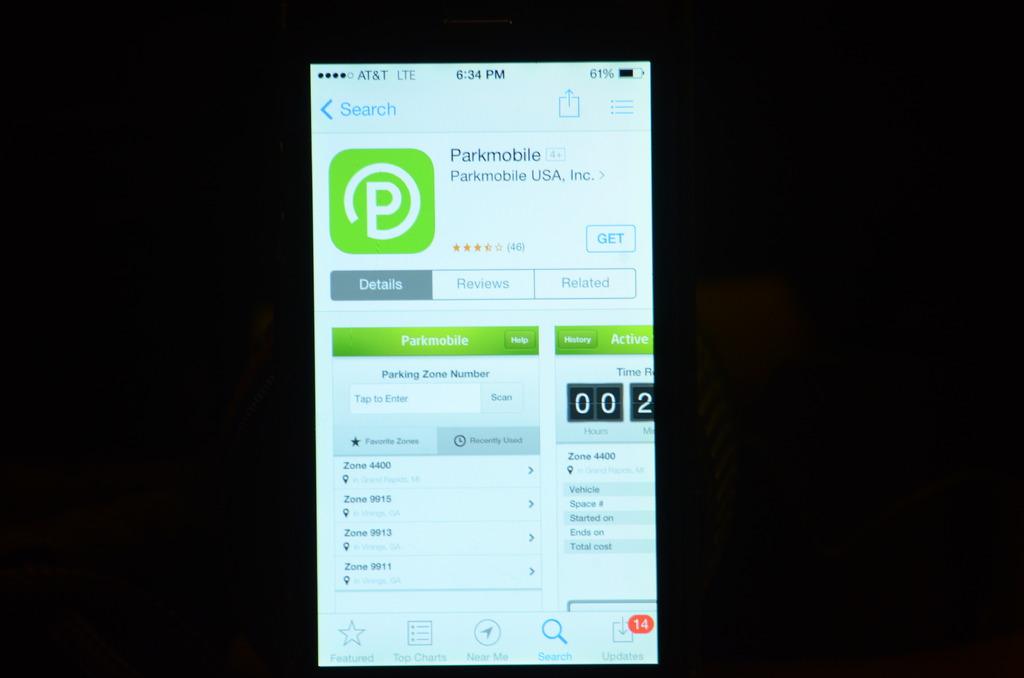Which cell phone provider do they have?
Provide a succinct answer. At&t. What is the name of the app?
Your answer should be very brief. Parkmobile. 